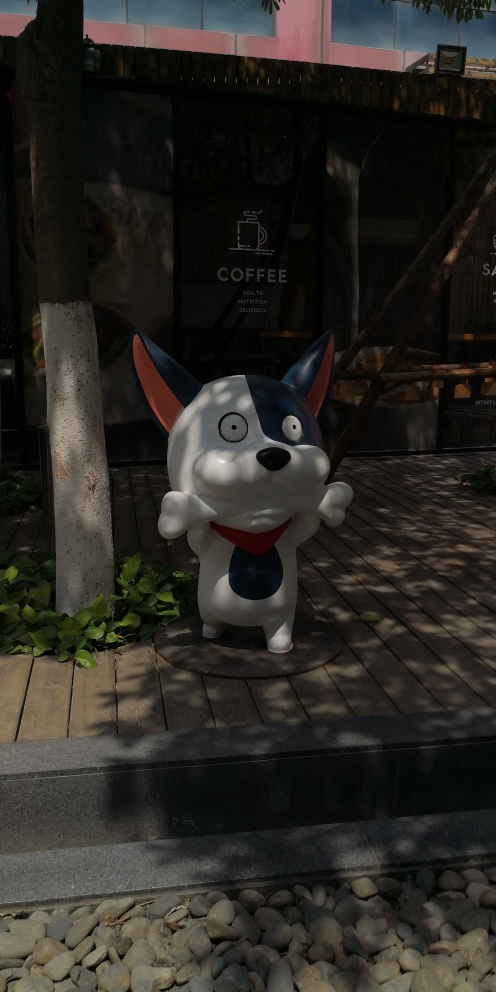How does the character’s design contribute to its visual impact? The character's design, with bright colors and an oversized, expressive face featuring large eyes and a wide smile, is crafted to immediately draw the eye and convey friendliness and joy. The use of simple, bold colors enhances visibility from a distance, making it effective as a visual magnet for potential customers. What does the setting tell us about the probable location of this coffee shop? The setting, with its wooden elements and gravel, combined with lush greenery and modern design elements, suggests a suburban or semi-urban area where aesthetic appeal and comfort are prioritized. This setting likely aims to provide a tranquil escape for coffee drinkers amid a relaxed yet modern environment. 